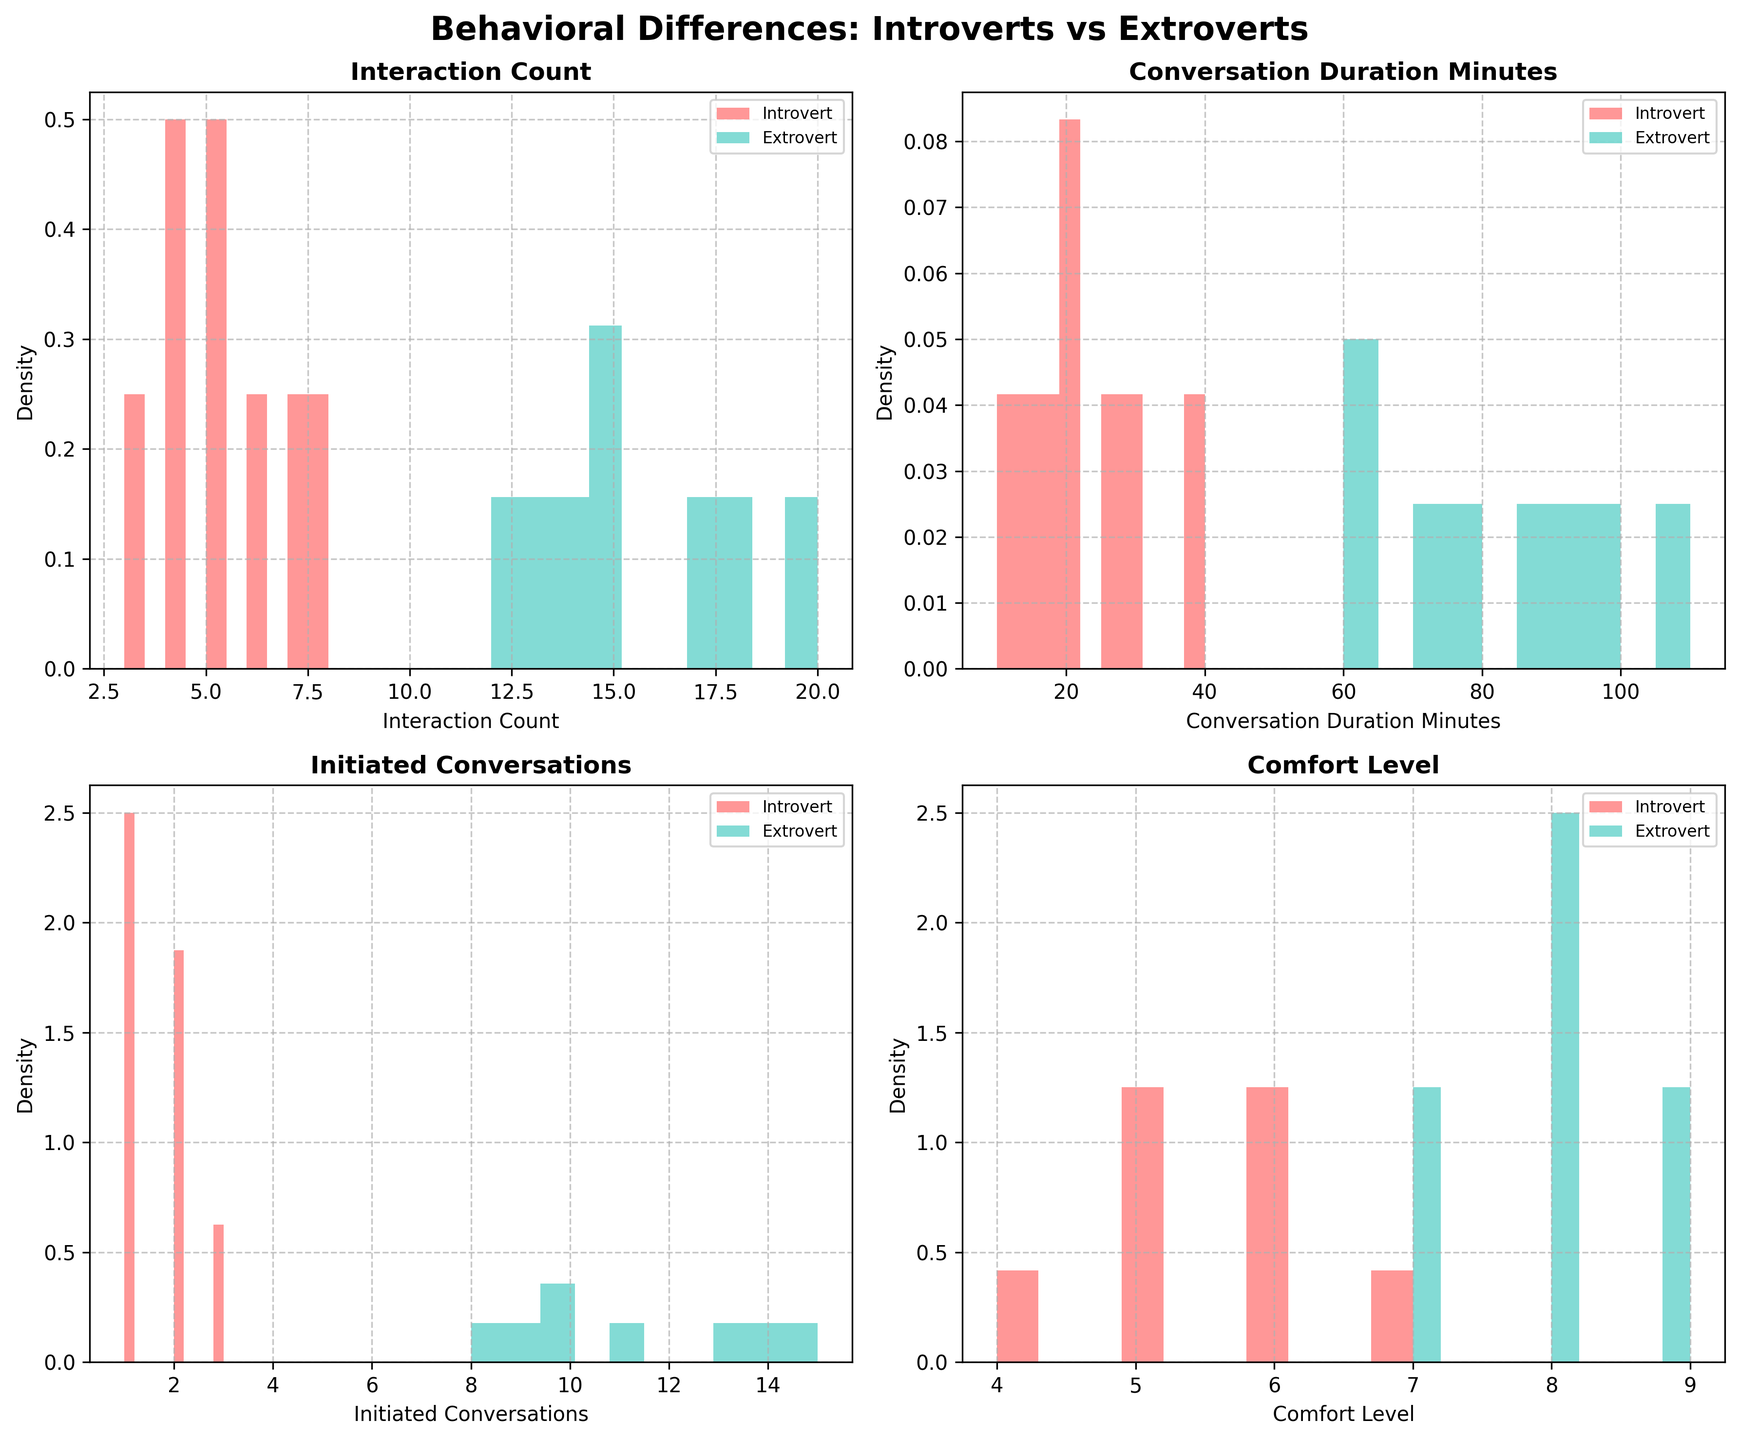How many subplots does the figure contain? The figure contains a grid layout of subplots, and based on the description, there are 2 rows and 2 columns, making a total of 4 subplots.
Answer: 4 What are the labels on the x-axis for the top left subplot? By looking at the features and arrangement, the top left subplot corresponds to 'Interaction Count'. The x-axis will be labeled 'Interaction Count'.
Answer: Interaction Count Which personality type has a higher density in the 'Conversation Duration Minutes' feature? By comparing the 'Conversation Duration Minutes' density plots of both personality types, the plot with the higher peaks or larger area under the curve represents the personality type with a higher density. Extroverts have higher density.
Answer: Extrovert Which subplot shows the 'Comfort Level' feature? Each subplot title corresponds to one of the features. 'Comfort Level' is listed as the fourth feature, so it will be in the bottom right subplot.
Answer: Bottom right In the 'Initiated Conversations' feature, does any personality type show a significantly higher peak density? By comparing the heights of density peaks for the 'Initiated Conversations' subplot, the personality type with a noticeable higher peak value can be identified, which is the Extroverts.
Answer: Extroverts Which personality type demonstrates a broader range of values in the 'Interaction Count'? By observing the spread of the histograms, the broader range of values can be identified as the one that covers more x-axis values. Extroverts show a broader range.
Answer: Extroverts What is the legend position in each subplot? In each subplot, the legend appears based on the descriptions and common practice; typically, legends are placed inside the plot area. The legend position is inside.
Answer: Inside How does the density distribution compare between introverts and extroverts on the 'Comfort Level' feature? By examining the density distribution's shape and peaks in the 'Comfort Level' subplot, we can compare the two types. The Extroverts' distribution has higher peaks and is skewed right, while the Introverts' distribution is more evenly spread.
Answer: Extroverts have higher peaks What's the highest density value observed in the 'Conversation Duration Minutes' feature for extroverts? By focusing on the 'Conversation Duration Minutes' subplot and observing the highest peak for Extroverts, we can identify the maximum density value. This value appears higher and more focused compared to Introverts.
Answer: Highest peak value seen 